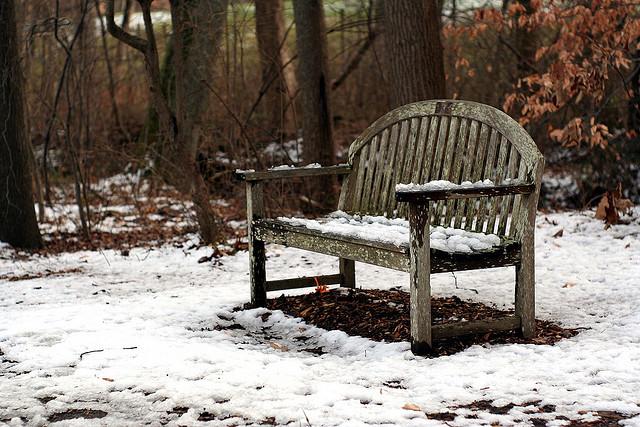What season is this?
Keep it brief. Winter. Is the bench made of wood?
Keep it brief. Yes. Is there snow?
Keep it brief. Yes. 